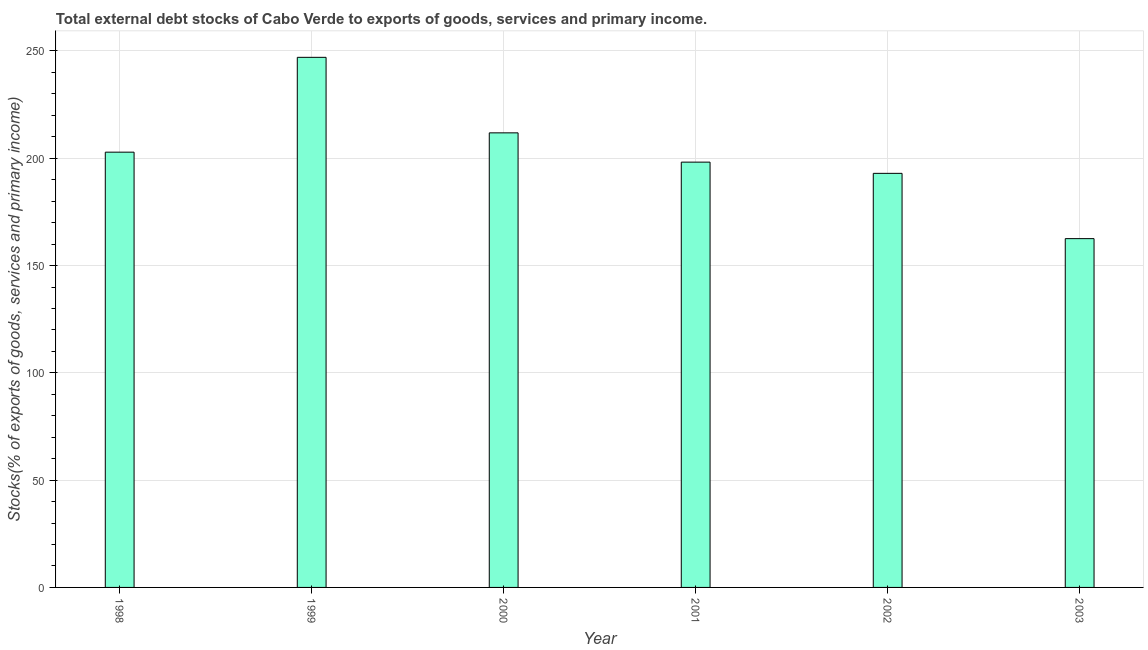Does the graph contain any zero values?
Your answer should be compact. No. What is the title of the graph?
Your answer should be very brief. Total external debt stocks of Cabo Verde to exports of goods, services and primary income. What is the label or title of the X-axis?
Give a very brief answer. Year. What is the label or title of the Y-axis?
Provide a succinct answer. Stocks(% of exports of goods, services and primary income). What is the external debt stocks in 2001?
Give a very brief answer. 198.21. Across all years, what is the maximum external debt stocks?
Offer a terse response. 247.05. Across all years, what is the minimum external debt stocks?
Make the answer very short. 162.55. In which year was the external debt stocks maximum?
Your answer should be compact. 1999. In which year was the external debt stocks minimum?
Offer a terse response. 2003. What is the sum of the external debt stocks?
Provide a succinct answer. 1215.49. What is the difference between the external debt stocks in 2000 and 2001?
Give a very brief answer. 13.64. What is the average external debt stocks per year?
Provide a short and direct response. 202.58. What is the median external debt stocks?
Ensure brevity in your answer.  200.53. What is the ratio of the external debt stocks in 1999 to that in 2002?
Your answer should be compact. 1.28. What is the difference between the highest and the second highest external debt stocks?
Provide a short and direct response. 35.2. Is the sum of the external debt stocks in 1998 and 2003 greater than the maximum external debt stocks across all years?
Your answer should be very brief. Yes. What is the difference between the highest and the lowest external debt stocks?
Provide a short and direct response. 84.49. In how many years, is the external debt stocks greater than the average external debt stocks taken over all years?
Offer a very short reply. 3. How many bars are there?
Your answer should be very brief. 6. Are all the bars in the graph horizontal?
Make the answer very short. No. How many years are there in the graph?
Ensure brevity in your answer.  6. What is the difference between two consecutive major ticks on the Y-axis?
Keep it short and to the point. 50. Are the values on the major ticks of Y-axis written in scientific E-notation?
Make the answer very short. No. What is the Stocks(% of exports of goods, services and primary income) in 1998?
Make the answer very short. 202.85. What is the Stocks(% of exports of goods, services and primary income) of 1999?
Keep it short and to the point. 247.05. What is the Stocks(% of exports of goods, services and primary income) in 2000?
Give a very brief answer. 211.85. What is the Stocks(% of exports of goods, services and primary income) of 2001?
Offer a very short reply. 198.21. What is the Stocks(% of exports of goods, services and primary income) in 2002?
Your answer should be compact. 192.98. What is the Stocks(% of exports of goods, services and primary income) in 2003?
Keep it short and to the point. 162.55. What is the difference between the Stocks(% of exports of goods, services and primary income) in 1998 and 1999?
Keep it short and to the point. -44.19. What is the difference between the Stocks(% of exports of goods, services and primary income) in 1998 and 2000?
Keep it short and to the point. -8.99. What is the difference between the Stocks(% of exports of goods, services and primary income) in 1998 and 2001?
Give a very brief answer. 4.65. What is the difference between the Stocks(% of exports of goods, services and primary income) in 1998 and 2002?
Your answer should be compact. 9.88. What is the difference between the Stocks(% of exports of goods, services and primary income) in 1998 and 2003?
Make the answer very short. 40.3. What is the difference between the Stocks(% of exports of goods, services and primary income) in 1999 and 2000?
Make the answer very short. 35.2. What is the difference between the Stocks(% of exports of goods, services and primary income) in 1999 and 2001?
Ensure brevity in your answer.  48.84. What is the difference between the Stocks(% of exports of goods, services and primary income) in 1999 and 2002?
Offer a terse response. 54.07. What is the difference between the Stocks(% of exports of goods, services and primary income) in 1999 and 2003?
Your answer should be very brief. 84.49. What is the difference between the Stocks(% of exports of goods, services and primary income) in 2000 and 2001?
Your response must be concise. 13.64. What is the difference between the Stocks(% of exports of goods, services and primary income) in 2000 and 2002?
Offer a terse response. 18.87. What is the difference between the Stocks(% of exports of goods, services and primary income) in 2000 and 2003?
Provide a short and direct response. 49.29. What is the difference between the Stocks(% of exports of goods, services and primary income) in 2001 and 2002?
Ensure brevity in your answer.  5.23. What is the difference between the Stocks(% of exports of goods, services and primary income) in 2001 and 2003?
Make the answer very short. 35.65. What is the difference between the Stocks(% of exports of goods, services and primary income) in 2002 and 2003?
Your answer should be compact. 30.43. What is the ratio of the Stocks(% of exports of goods, services and primary income) in 1998 to that in 1999?
Keep it short and to the point. 0.82. What is the ratio of the Stocks(% of exports of goods, services and primary income) in 1998 to that in 2000?
Provide a succinct answer. 0.96. What is the ratio of the Stocks(% of exports of goods, services and primary income) in 1998 to that in 2001?
Your answer should be very brief. 1.02. What is the ratio of the Stocks(% of exports of goods, services and primary income) in 1998 to that in 2002?
Offer a very short reply. 1.05. What is the ratio of the Stocks(% of exports of goods, services and primary income) in 1998 to that in 2003?
Provide a succinct answer. 1.25. What is the ratio of the Stocks(% of exports of goods, services and primary income) in 1999 to that in 2000?
Your answer should be very brief. 1.17. What is the ratio of the Stocks(% of exports of goods, services and primary income) in 1999 to that in 2001?
Give a very brief answer. 1.25. What is the ratio of the Stocks(% of exports of goods, services and primary income) in 1999 to that in 2002?
Ensure brevity in your answer.  1.28. What is the ratio of the Stocks(% of exports of goods, services and primary income) in 1999 to that in 2003?
Your response must be concise. 1.52. What is the ratio of the Stocks(% of exports of goods, services and primary income) in 2000 to that in 2001?
Offer a terse response. 1.07. What is the ratio of the Stocks(% of exports of goods, services and primary income) in 2000 to that in 2002?
Your answer should be very brief. 1.1. What is the ratio of the Stocks(% of exports of goods, services and primary income) in 2000 to that in 2003?
Provide a succinct answer. 1.3. What is the ratio of the Stocks(% of exports of goods, services and primary income) in 2001 to that in 2002?
Keep it short and to the point. 1.03. What is the ratio of the Stocks(% of exports of goods, services and primary income) in 2001 to that in 2003?
Offer a very short reply. 1.22. What is the ratio of the Stocks(% of exports of goods, services and primary income) in 2002 to that in 2003?
Provide a short and direct response. 1.19. 